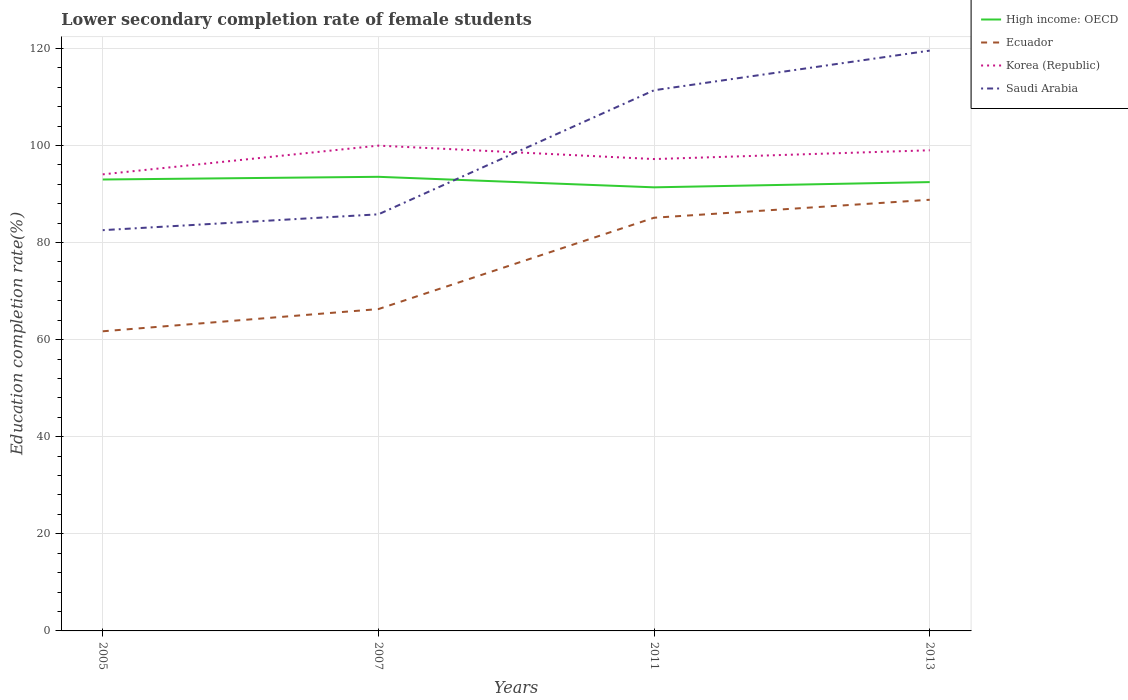How many different coloured lines are there?
Your response must be concise. 4. Does the line corresponding to Saudi Arabia intersect with the line corresponding to High income: OECD?
Offer a very short reply. Yes. Is the number of lines equal to the number of legend labels?
Make the answer very short. Yes. Across all years, what is the maximum lower secondary completion rate of female students in Ecuador?
Provide a short and direct response. 61.72. In which year was the lower secondary completion rate of female students in Saudi Arabia maximum?
Give a very brief answer. 2005. What is the total lower secondary completion rate of female students in High income: OECD in the graph?
Keep it short and to the point. 1.61. What is the difference between the highest and the second highest lower secondary completion rate of female students in Korea (Republic)?
Your answer should be compact. 5.92. What is the difference between the highest and the lowest lower secondary completion rate of female students in Ecuador?
Offer a very short reply. 2. How many lines are there?
Ensure brevity in your answer.  4. What is the difference between two consecutive major ticks on the Y-axis?
Provide a succinct answer. 20. Does the graph contain any zero values?
Your response must be concise. No. How many legend labels are there?
Your response must be concise. 4. What is the title of the graph?
Provide a succinct answer. Lower secondary completion rate of female students. Does "Eritrea" appear as one of the legend labels in the graph?
Your answer should be compact. No. What is the label or title of the X-axis?
Provide a short and direct response. Years. What is the label or title of the Y-axis?
Make the answer very short. Education completion rate(%). What is the Education completion rate(%) of High income: OECD in 2005?
Offer a terse response. 92.98. What is the Education completion rate(%) in Ecuador in 2005?
Offer a very short reply. 61.72. What is the Education completion rate(%) in Korea (Republic) in 2005?
Ensure brevity in your answer.  94.05. What is the Education completion rate(%) of Saudi Arabia in 2005?
Your answer should be very brief. 82.55. What is the Education completion rate(%) of High income: OECD in 2007?
Offer a very short reply. 93.54. What is the Education completion rate(%) in Ecuador in 2007?
Your answer should be compact. 66.29. What is the Education completion rate(%) in Korea (Republic) in 2007?
Give a very brief answer. 99.96. What is the Education completion rate(%) of Saudi Arabia in 2007?
Your response must be concise. 85.81. What is the Education completion rate(%) in High income: OECD in 2011?
Your response must be concise. 91.37. What is the Education completion rate(%) in Ecuador in 2011?
Give a very brief answer. 85.11. What is the Education completion rate(%) of Korea (Republic) in 2011?
Provide a succinct answer. 97.19. What is the Education completion rate(%) of Saudi Arabia in 2011?
Your answer should be compact. 111.37. What is the Education completion rate(%) of High income: OECD in 2013?
Provide a succinct answer. 92.45. What is the Education completion rate(%) of Ecuador in 2013?
Make the answer very short. 88.81. What is the Education completion rate(%) of Korea (Republic) in 2013?
Make the answer very short. 99. What is the Education completion rate(%) of Saudi Arabia in 2013?
Make the answer very short. 119.53. Across all years, what is the maximum Education completion rate(%) of High income: OECD?
Your response must be concise. 93.54. Across all years, what is the maximum Education completion rate(%) in Ecuador?
Ensure brevity in your answer.  88.81. Across all years, what is the maximum Education completion rate(%) of Korea (Republic)?
Your answer should be very brief. 99.96. Across all years, what is the maximum Education completion rate(%) in Saudi Arabia?
Keep it short and to the point. 119.53. Across all years, what is the minimum Education completion rate(%) in High income: OECD?
Your answer should be very brief. 91.37. Across all years, what is the minimum Education completion rate(%) of Ecuador?
Your answer should be compact. 61.72. Across all years, what is the minimum Education completion rate(%) in Korea (Republic)?
Provide a succinct answer. 94.05. Across all years, what is the minimum Education completion rate(%) in Saudi Arabia?
Your response must be concise. 82.55. What is the total Education completion rate(%) of High income: OECD in the graph?
Provide a short and direct response. 370.34. What is the total Education completion rate(%) in Ecuador in the graph?
Provide a succinct answer. 301.93. What is the total Education completion rate(%) in Korea (Republic) in the graph?
Your answer should be compact. 390.21. What is the total Education completion rate(%) in Saudi Arabia in the graph?
Offer a very short reply. 399.26. What is the difference between the Education completion rate(%) in High income: OECD in 2005 and that in 2007?
Offer a very short reply. -0.56. What is the difference between the Education completion rate(%) of Ecuador in 2005 and that in 2007?
Your response must be concise. -4.57. What is the difference between the Education completion rate(%) in Korea (Republic) in 2005 and that in 2007?
Keep it short and to the point. -5.92. What is the difference between the Education completion rate(%) in Saudi Arabia in 2005 and that in 2007?
Provide a short and direct response. -3.26. What is the difference between the Education completion rate(%) in High income: OECD in 2005 and that in 2011?
Your response must be concise. 1.61. What is the difference between the Education completion rate(%) of Ecuador in 2005 and that in 2011?
Provide a succinct answer. -23.39. What is the difference between the Education completion rate(%) in Korea (Republic) in 2005 and that in 2011?
Provide a short and direct response. -3.15. What is the difference between the Education completion rate(%) of Saudi Arabia in 2005 and that in 2011?
Provide a succinct answer. -28.82. What is the difference between the Education completion rate(%) in High income: OECD in 2005 and that in 2013?
Provide a succinct answer. 0.53. What is the difference between the Education completion rate(%) in Ecuador in 2005 and that in 2013?
Your answer should be compact. -27.09. What is the difference between the Education completion rate(%) in Korea (Republic) in 2005 and that in 2013?
Your answer should be compact. -4.96. What is the difference between the Education completion rate(%) in Saudi Arabia in 2005 and that in 2013?
Give a very brief answer. -36.98. What is the difference between the Education completion rate(%) of High income: OECD in 2007 and that in 2011?
Make the answer very short. 2.17. What is the difference between the Education completion rate(%) of Ecuador in 2007 and that in 2011?
Ensure brevity in your answer.  -18.82. What is the difference between the Education completion rate(%) of Korea (Republic) in 2007 and that in 2011?
Give a very brief answer. 2.77. What is the difference between the Education completion rate(%) of Saudi Arabia in 2007 and that in 2011?
Offer a terse response. -25.56. What is the difference between the Education completion rate(%) of High income: OECD in 2007 and that in 2013?
Keep it short and to the point. 1.09. What is the difference between the Education completion rate(%) in Ecuador in 2007 and that in 2013?
Provide a short and direct response. -22.52. What is the difference between the Education completion rate(%) in Korea (Republic) in 2007 and that in 2013?
Make the answer very short. 0.96. What is the difference between the Education completion rate(%) in Saudi Arabia in 2007 and that in 2013?
Offer a very short reply. -33.72. What is the difference between the Education completion rate(%) of High income: OECD in 2011 and that in 2013?
Give a very brief answer. -1.08. What is the difference between the Education completion rate(%) in Ecuador in 2011 and that in 2013?
Provide a succinct answer. -3.7. What is the difference between the Education completion rate(%) in Korea (Republic) in 2011 and that in 2013?
Give a very brief answer. -1.81. What is the difference between the Education completion rate(%) in Saudi Arabia in 2011 and that in 2013?
Provide a short and direct response. -8.17. What is the difference between the Education completion rate(%) of High income: OECD in 2005 and the Education completion rate(%) of Ecuador in 2007?
Offer a terse response. 26.69. What is the difference between the Education completion rate(%) in High income: OECD in 2005 and the Education completion rate(%) in Korea (Republic) in 2007?
Make the answer very short. -6.98. What is the difference between the Education completion rate(%) in High income: OECD in 2005 and the Education completion rate(%) in Saudi Arabia in 2007?
Keep it short and to the point. 7.17. What is the difference between the Education completion rate(%) in Ecuador in 2005 and the Education completion rate(%) in Korea (Republic) in 2007?
Offer a very short reply. -38.24. What is the difference between the Education completion rate(%) of Ecuador in 2005 and the Education completion rate(%) of Saudi Arabia in 2007?
Offer a terse response. -24.09. What is the difference between the Education completion rate(%) of Korea (Republic) in 2005 and the Education completion rate(%) of Saudi Arabia in 2007?
Offer a very short reply. 8.23. What is the difference between the Education completion rate(%) of High income: OECD in 2005 and the Education completion rate(%) of Ecuador in 2011?
Provide a succinct answer. 7.87. What is the difference between the Education completion rate(%) in High income: OECD in 2005 and the Education completion rate(%) in Korea (Republic) in 2011?
Your answer should be compact. -4.21. What is the difference between the Education completion rate(%) of High income: OECD in 2005 and the Education completion rate(%) of Saudi Arabia in 2011?
Keep it short and to the point. -18.38. What is the difference between the Education completion rate(%) of Ecuador in 2005 and the Education completion rate(%) of Korea (Republic) in 2011?
Provide a short and direct response. -35.48. What is the difference between the Education completion rate(%) of Ecuador in 2005 and the Education completion rate(%) of Saudi Arabia in 2011?
Give a very brief answer. -49.65. What is the difference between the Education completion rate(%) of Korea (Republic) in 2005 and the Education completion rate(%) of Saudi Arabia in 2011?
Your response must be concise. -17.32. What is the difference between the Education completion rate(%) of High income: OECD in 2005 and the Education completion rate(%) of Ecuador in 2013?
Your answer should be very brief. 4.17. What is the difference between the Education completion rate(%) in High income: OECD in 2005 and the Education completion rate(%) in Korea (Republic) in 2013?
Keep it short and to the point. -6.02. What is the difference between the Education completion rate(%) in High income: OECD in 2005 and the Education completion rate(%) in Saudi Arabia in 2013?
Keep it short and to the point. -26.55. What is the difference between the Education completion rate(%) in Ecuador in 2005 and the Education completion rate(%) in Korea (Republic) in 2013?
Make the answer very short. -37.28. What is the difference between the Education completion rate(%) in Ecuador in 2005 and the Education completion rate(%) in Saudi Arabia in 2013?
Make the answer very short. -57.81. What is the difference between the Education completion rate(%) of Korea (Republic) in 2005 and the Education completion rate(%) of Saudi Arabia in 2013?
Give a very brief answer. -25.49. What is the difference between the Education completion rate(%) in High income: OECD in 2007 and the Education completion rate(%) in Ecuador in 2011?
Provide a short and direct response. 8.43. What is the difference between the Education completion rate(%) in High income: OECD in 2007 and the Education completion rate(%) in Korea (Republic) in 2011?
Ensure brevity in your answer.  -3.66. What is the difference between the Education completion rate(%) in High income: OECD in 2007 and the Education completion rate(%) in Saudi Arabia in 2011?
Your answer should be very brief. -17.83. What is the difference between the Education completion rate(%) of Ecuador in 2007 and the Education completion rate(%) of Korea (Republic) in 2011?
Keep it short and to the point. -30.9. What is the difference between the Education completion rate(%) in Ecuador in 2007 and the Education completion rate(%) in Saudi Arabia in 2011?
Make the answer very short. -45.07. What is the difference between the Education completion rate(%) in Korea (Republic) in 2007 and the Education completion rate(%) in Saudi Arabia in 2011?
Give a very brief answer. -11.4. What is the difference between the Education completion rate(%) of High income: OECD in 2007 and the Education completion rate(%) of Ecuador in 2013?
Your response must be concise. 4.73. What is the difference between the Education completion rate(%) in High income: OECD in 2007 and the Education completion rate(%) in Korea (Republic) in 2013?
Offer a very short reply. -5.46. What is the difference between the Education completion rate(%) in High income: OECD in 2007 and the Education completion rate(%) in Saudi Arabia in 2013?
Your answer should be very brief. -25.99. What is the difference between the Education completion rate(%) in Ecuador in 2007 and the Education completion rate(%) in Korea (Republic) in 2013?
Offer a terse response. -32.71. What is the difference between the Education completion rate(%) in Ecuador in 2007 and the Education completion rate(%) in Saudi Arabia in 2013?
Offer a very short reply. -53.24. What is the difference between the Education completion rate(%) of Korea (Republic) in 2007 and the Education completion rate(%) of Saudi Arabia in 2013?
Ensure brevity in your answer.  -19.57. What is the difference between the Education completion rate(%) of High income: OECD in 2011 and the Education completion rate(%) of Ecuador in 2013?
Offer a terse response. 2.56. What is the difference between the Education completion rate(%) in High income: OECD in 2011 and the Education completion rate(%) in Korea (Republic) in 2013?
Your answer should be very brief. -7.63. What is the difference between the Education completion rate(%) of High income: OECD in 2011 and the Education completion rate(%) of Saudi Arabia in 2013?
Give a very brief answer. -28.16. What is the difference between the Education completion rate(%) of Ecuador in 2011 and the Education completion rate(%) of Korea (Republic) in 2013?
Your answer should be very brief. -13.89. What is the difference between the Education completion rate(%) in Ecuador in 2011 and the Education completion rate(%) in Saudi Arabia in 2013?
Provide a short and direct response. -34.42. What is the difference between the Education completion rate(%) of Korea (Republic) in 2011 and the Education completion rate(%) of Saudi Arabia in 2013?
Give a very brief answer. -22.34. What is the average Education completion rate(%) of High income: OECD per year?
Ensure brevity in your answer.  92.59. What is the average Education completion rate(%) of Ecuador per year?
Give a very brief answer. 75.48. What is the average Education completion rate(%) of Korea (Republic) per year?
Provide a succinct answer. 97.55. What is the average Education completion rate(%) in Saudi Arabia per year?
Offer a terse response. 99.82. In the year 2005, what is the difference between the Education completion rate(%) of High income: OECD and Education completion rate(%) of Ecuador?
Your answer should be compact. 31.26. In the year 2005, what is the difference between the Education completion rate(%) in High income: OECD and Education completion rate(%) in Korea (Republic)?
Provide a succinct answer. -1.06. In the year 2005, what is the difference between the Education completion rate(%) in High income: OECD and Education completion rate(%) in Saudi Arabia?
Give a very brief answer. 10.44. In the year 2005, what is the difference between the Education completion rate(%) of Ecuador and Education completion rate(%) of Korea (Republic)?
Give a very brief answer. -32.33. In the year 2005, what is the difference between the Education completion rate(%) of Ecuador and Education completion rate(%) of Saudi Arabia?
Keep it short and to the point. -20.83. In the year 2005, what is the difference between the Education completion rate(%) of Korea (Republic) and Education completion rate(%) of Saudi Arabia?
Offer a terse response. 11.5. In the year 2007, what is the difference between the Education completion rate(%) of High income: OECD and Education completion rate(%) of Ecuador?
Keep it short and to the point. 27.25. In the year 2007, what is the difference between the Education completion rate(%) of High income: OECD and Education completion rate(%) of Korea (Republic)?
Offer a very short reply. -6.42. In the year 2007, what is the difference between the Education completion rate(%) in High income: OECD and Education completion rate(%) in Saudi Arabia?
Provide a short and direct response. 7.73. In the year 2007, what is the difference between the Education completion rate(%) of Ecuador and Education completion rate(%) of Korea (Republic)?
Make the answer very short. -33.67. In the year 2007, what is the difference between the Education completion rate(%) in Ecuador and Education completion rate(%) in Saudi Arabia?
Make the answer very short. -19.52. In the year 2007, what is the difference between the Education completion rate(%) of Korea (Republic) and Education completion rate(%) of Saudi Arabia?
Your answer should be very brief. 14.15. In the year 2011, what is the difference between the Education completion rate(%) in High income: OECD and Education completion rate(%) in Ecuador?
Keep it short and to the point. 6.26. In the year 2011, what is the difference between the Education completion rate(%) of High income: OECD and Education completion rate(%) of Korea (Republic)?
Give a very brief answer. -5.82. In the year 2011, what is the difference between the Education completion rate(%) in High income: OECD and Education completion rate(%) in Saudi Arabia?
Offer a terse response. -20. In the year 2011, what is the difference between the Education completion rate(%) in Ecuador and Education completion rate(%) in Korea (Republic)?
Ensure brevity in your answer.  -12.08. In the year 2011, what is the difference between the Education completion rate(%) in Ecuador and Education completion rate(%) in Saudi Arabia?
Offer a very short reply. -26.26. In the year 2011, what is the difference between the Education completion rate(%) in Korea (Republic) and Education completion rate(%) in Saudi Arabia?
Provide a succinct answer. -14.17. In the year 2013, what is the difference between the Education completion rate(%) of High income: OECD and Education completion rate(%) of Ecuador?
Provide a short and direct response. 3.64. In the year 2013, what is the difference between the Education completion rate(%) in High income: OECD and Education completion rate(%) in Korea (Republic)?
Give a very brief answer. -6.55. In the year 2013, what is the difference between the Education completion rate(%) of High income: OECD and Education completion rate(%) of Saudi Arabia?
Your response must be concise. -27.08. In the year 2013, what is the difference between the Education completion rate(%) of Ecuador and Education completion rate(%) of Korea (Republic)?
Provide a succinct answer. -10.19. In the year 2013, what is the difference between the Education completion rate(%) of Ecuador and Education completion rate(%) of Saudi Arabia?
Give a very brief answer. -30.72. In the year 2013, what is the difference between the Education completion rate(%) in Korea (Republic) and Education completion rate(%) in Saudi Arabia?
Offer a terse response. -20.53. What is the ratio of the Education completion rate(%) of Korea (Republic) in 2005 to that in 2007?
Provide a short and direct response. 0.94. What is the ratio of the Education completion rate(%) of High income: OECD in 2005 to that in 2011?
Your answer should be very brief. 1.02. What is the ratio of the Education completion rate(%) of Ecuador in 2005 to that in 2011?
Your answer should be very brief. 0.73. What is the ratio of the Education completion rate(%) of Korea (Republic) in 2005 to that in 2011?
Provide a short and direct response. 0.97. What is the ratio of the Education completion rate(%) in Saudi Arabia in 2005 to that in 2011?
Keep it short and to the point. 0.74. What is the ratio of the Education completion rate(%) in High income: OECD in 2005 to that in 2013?
Offer a very short reply. 1.01. What is the ratio of the Education completion rate(%) of Ecuador in 2005 to that in 2013?
Keep it short and to the point. 0.69. What is the ratio of the Education completion rate(%) in Korea (Republic) in 2005 to that in 2013?
Keep it short and to the point. 0.95. What is the ratio of the Education completion rate(%) of Saudi Arabia in 2005 to that in 2013?
Your answer should be compact. 0.69. What is the ratio of the Education completion rate(%) of High income: OECD in 2007 to that in 2011?
Offer a very short reply. 1.02. What is the ratio of the Education completion rate(%) in Ecuador in 2007 to that in 2011?
Ensure brevity in your answer.  0.78. What is the ratio of the Education completion rate(%) of Korea (Republic) in 2007 to that in 2011?
Make the answer very short. 1.03. What is the ratio of the Education completion rate(%) in Saudi Arabia in 2007 to that in 2011?
Keep it short and to the point. 0.77. What is the ratio of the Education completion rate(%) in High income: OECD in 2007 to that in 2013?
Offer a terse response. 1.01. What is the ratio of the Education completion rate(%) in Ecuador in 2007 to that in 2013?
Your response must be concise. 0.75. What is the ratio of the Education completion rate(%) of Korea (Republic) in 2007 to that in 2013?
Offer a very short reply. 1.01. What is the ratio of the Education completion rate(%) in Saudi Arabia in 2007 to that in 2013?
Provide a succinct answer. 0.72. What is the ratio of the Education completion rate(%) of High income: OECD in 2011 to that in 2013?
Make the answer very short. 0.99. What is the ratio of the Education completion rate(%) in Korea (Republic) in 2011 to that in 2013?
Your answer should be very brief. 0.98. What is the ratio of the Education completion rate(%) in Saudi Arabia in 2011 to that in 2013?
Keep it short and to the point. 0.93. What is the difference between the highest and the second highest Education completion rate(%) of High income: OECD?
Your answer should be compact. 0.56. What is the difference between the highest and the second highest Education completion rate(%) of Ecuador?
Ensure brevity in your answer.  3.7. What is the difference between the highest and the second highest Education completion rate(%) of Korea (Republic)?
Your answer should be compact. 0.96. What is the difference between the highest and the second highest Education completion rate(%) of Saudi Arabia?
Provide a succinct answer. 8.17. What is the difference between the highest and the lowest Education completion rate(%) of High income: OECD?
Ensure brevity in your answer.  2.17. What is the difference between the highest and the lowest Education completion rate(%) of Ecuador?
Offer a terse response. 27.09. What is the difference between the highest and the lowest Education completion rate(%) of Korea (Republic)?
Offer a very short reply. 5.92. What is the difference between the highest and the lowest Education completion rate(%) of Saudi Arabia?
Ensure brevity in your answer.  36.98. 